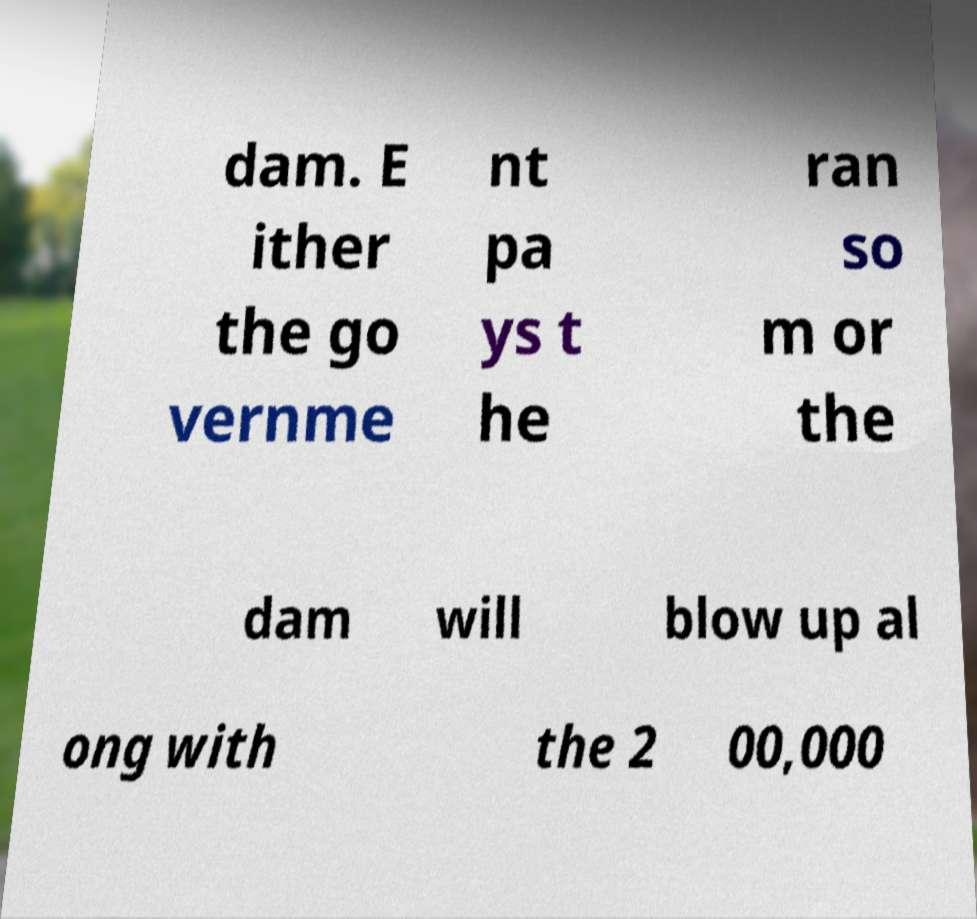Can you accurately transcribe the text from the provided image for me? dam. E ither the go vernme nt pa ys t he ran so m or the dam will blow up al ong with the 2 00,000 